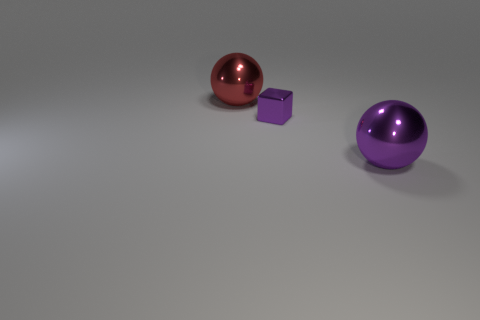Add 1 large red objects. How many objects exist? 4 Subtract all cubes. How many objects are left? 2 Add 2 big purple shiny balls. How many big purple shiny balls exist? 3 Subtract 0 yellow spheres. How many objects are left? 3 Subtract all large yellow cubes. Subtract all red metal balls. How many objects are left? 2 Add 2 large objects. How many large objects are left? 4 